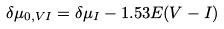<formula> <loc_0><loc_0><loc_500><loc_500>\delta \mu _ { 0 , V I } = \delta \mu _ { I } - 1 . 5 3 E ( V - I )</formula> 